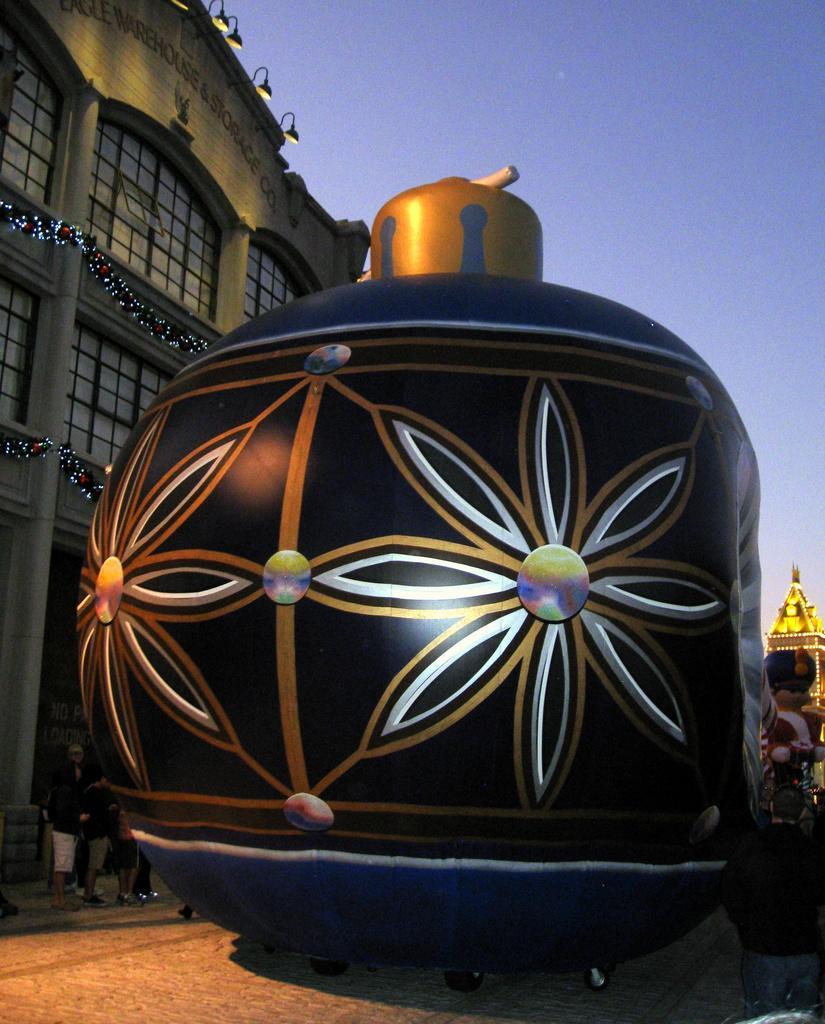Please provide a concise description of this image. In this image I can see an object which is in black color, background I can see few persons standing, few lights, a building in cream color and the sky is in blue color. 